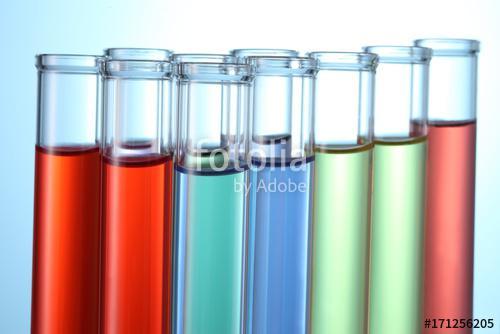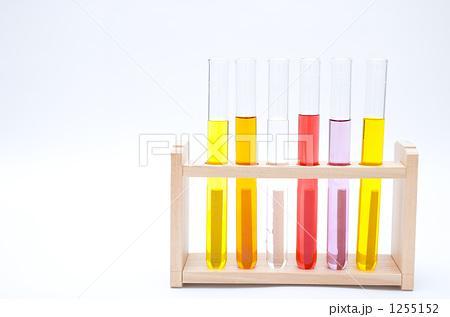The first image is the image on the left, the second image is the image on the right. Given the left and right images, does the statement "The left image shows a beaker of purple liquid to the front and right of a stand containing test tubes, at least two with purple liquid in them." hold true? Answer yes or no. No. The first image is the image on the left, the second image is the image on the right. Analyze the images presented: Is the assertion "The containers in each of the images are all long and slender." valid? Answer yes or no. Yes. 